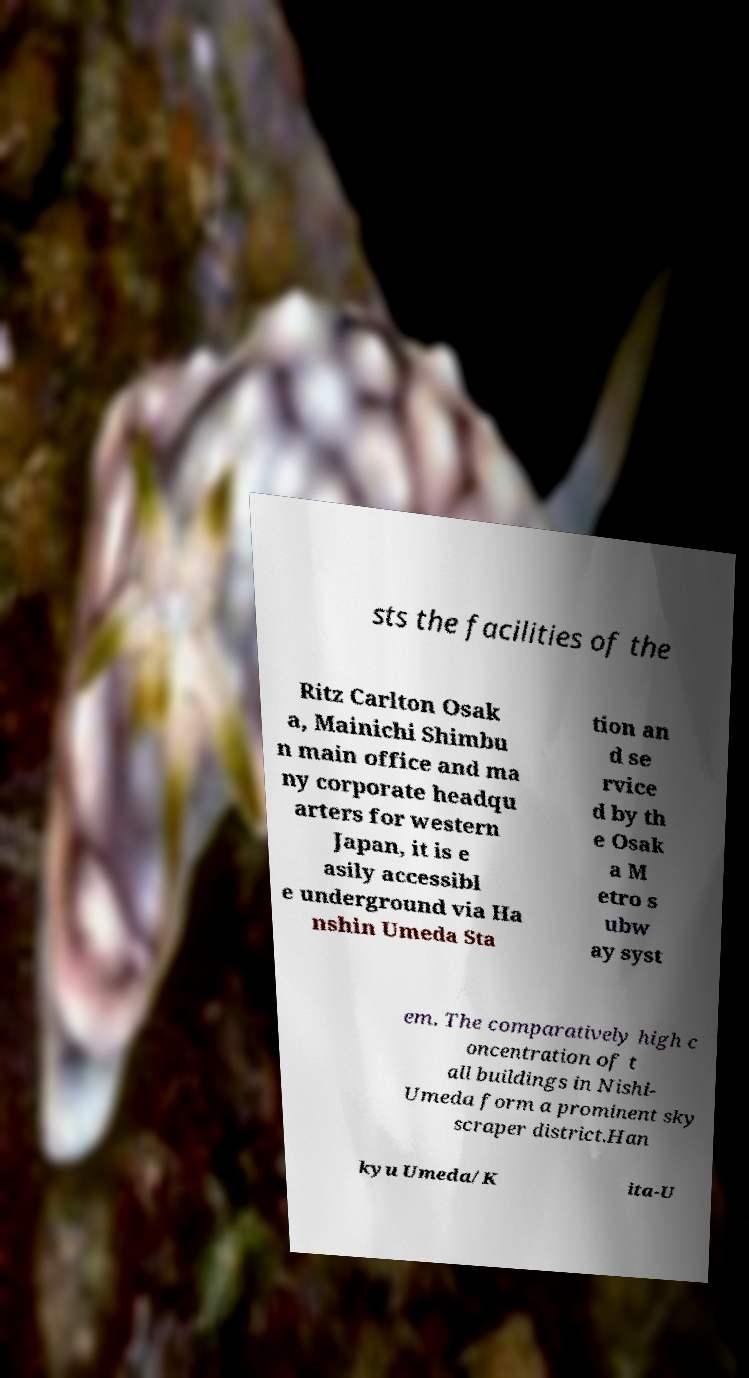I need the written content from this picture converted into text. Can you do that? sts the facilities of the Ritz Carlton Osak a, Mainichi Shimbu n main office and ma ny corporate headqu arters for western Japan, it is e asily accessibl e underground via Ha nshin Umeda Sta tion an d se rvice d by th e Osak a M etro s ubw ay syst em. The comparatively high c oncentration of t all buildings in Nishi- Umeda form a prominent sky scraper district.Han kyu Umeda/K ita-U 